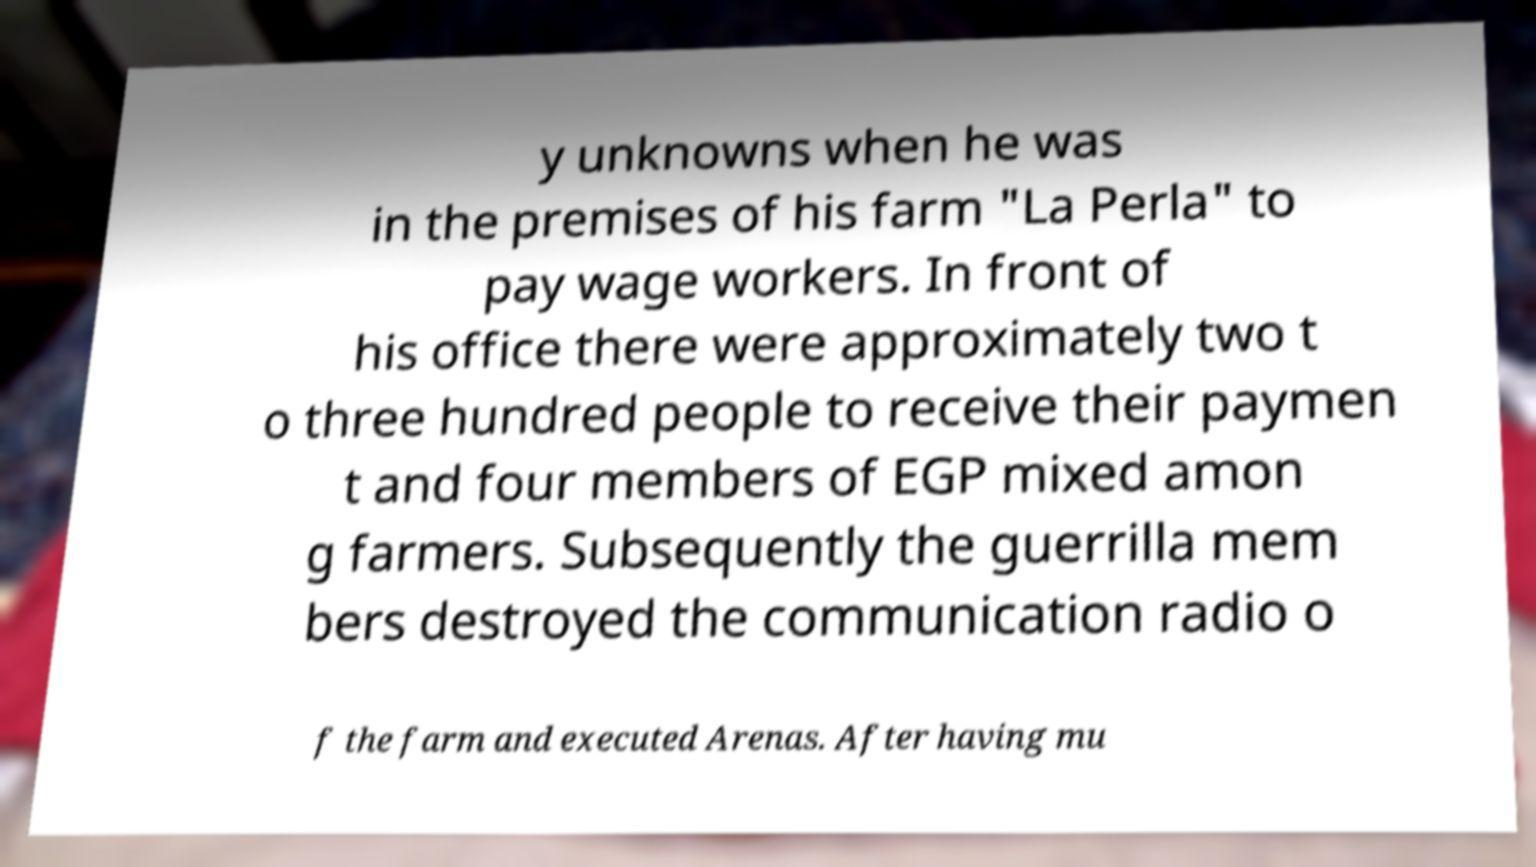Could you extract and type out the text from this image? y unknowns when he was in the premises of his farm "La Perla" to pay wage workers. In front of his office there were approximately two t o three hundred people to receive their paymen t and four members of EGP mixed amon g farmers. Subsequently the guerrilla mem bers destroyed the communication radio o f the farm and executed Arenas. After having mu 